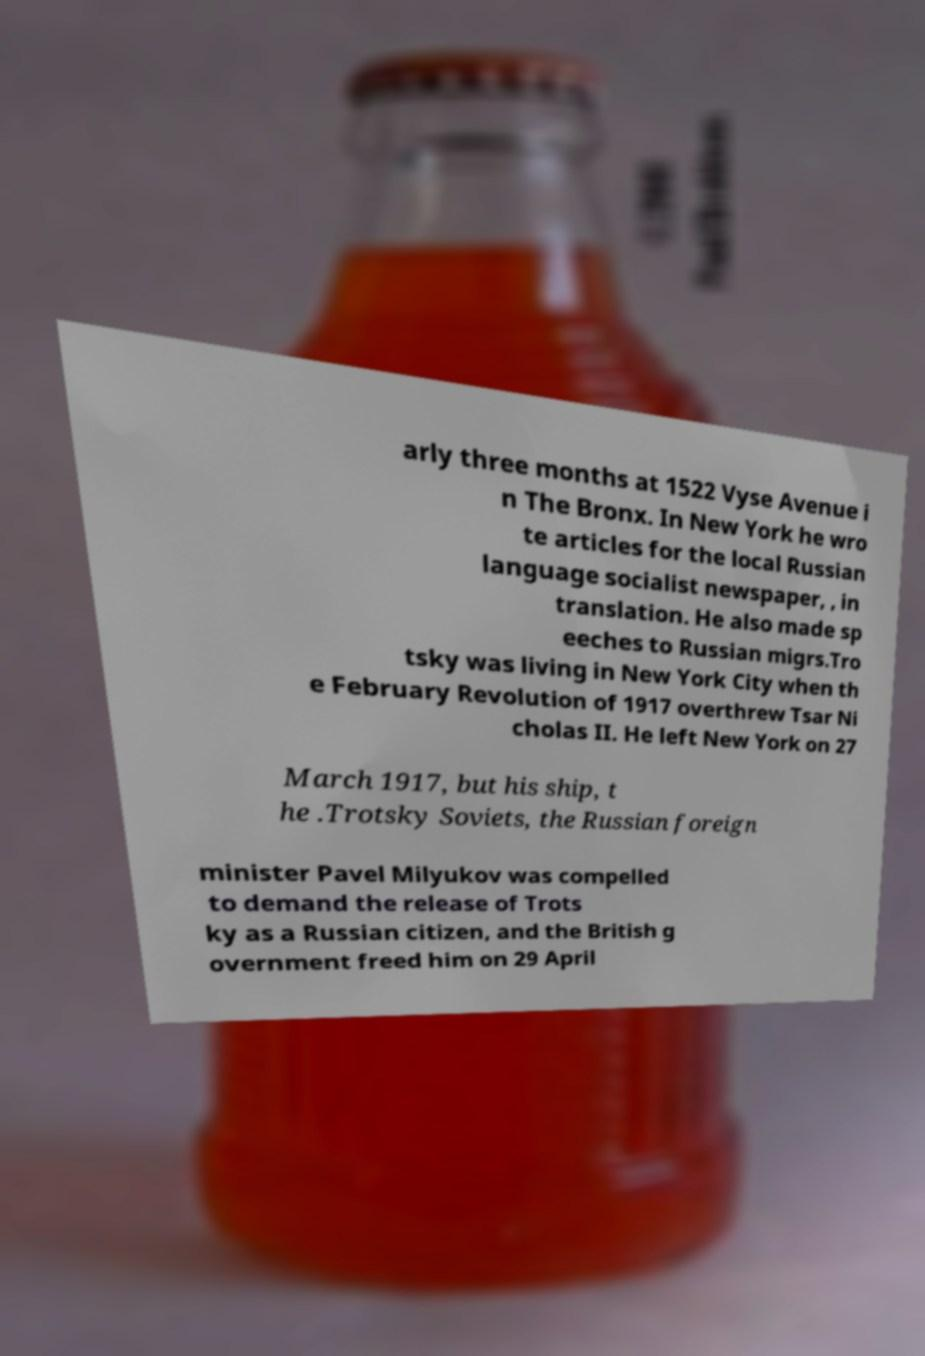What messages or text are displayed in this image? I need them in a readable, typed format. arly three months at 1522 Vyse Avenue i n The Bronx. In New York he wro te articles for the local Russian language socialist newspaper, , in translation. He also made sp eeches to Russian migrs.Tro tsky was living in New York City when th e February Revolution of 1917 overthrew Tsar Ni cholas II. He left New York on 27 March 1917, but his ship, t he .Trotsky Soviets, the Russian foreign minister Pavel Milyukov was compelled to demand the release of Trots ky as a Russian citizen, and the British g overnment freed him on 29 April 